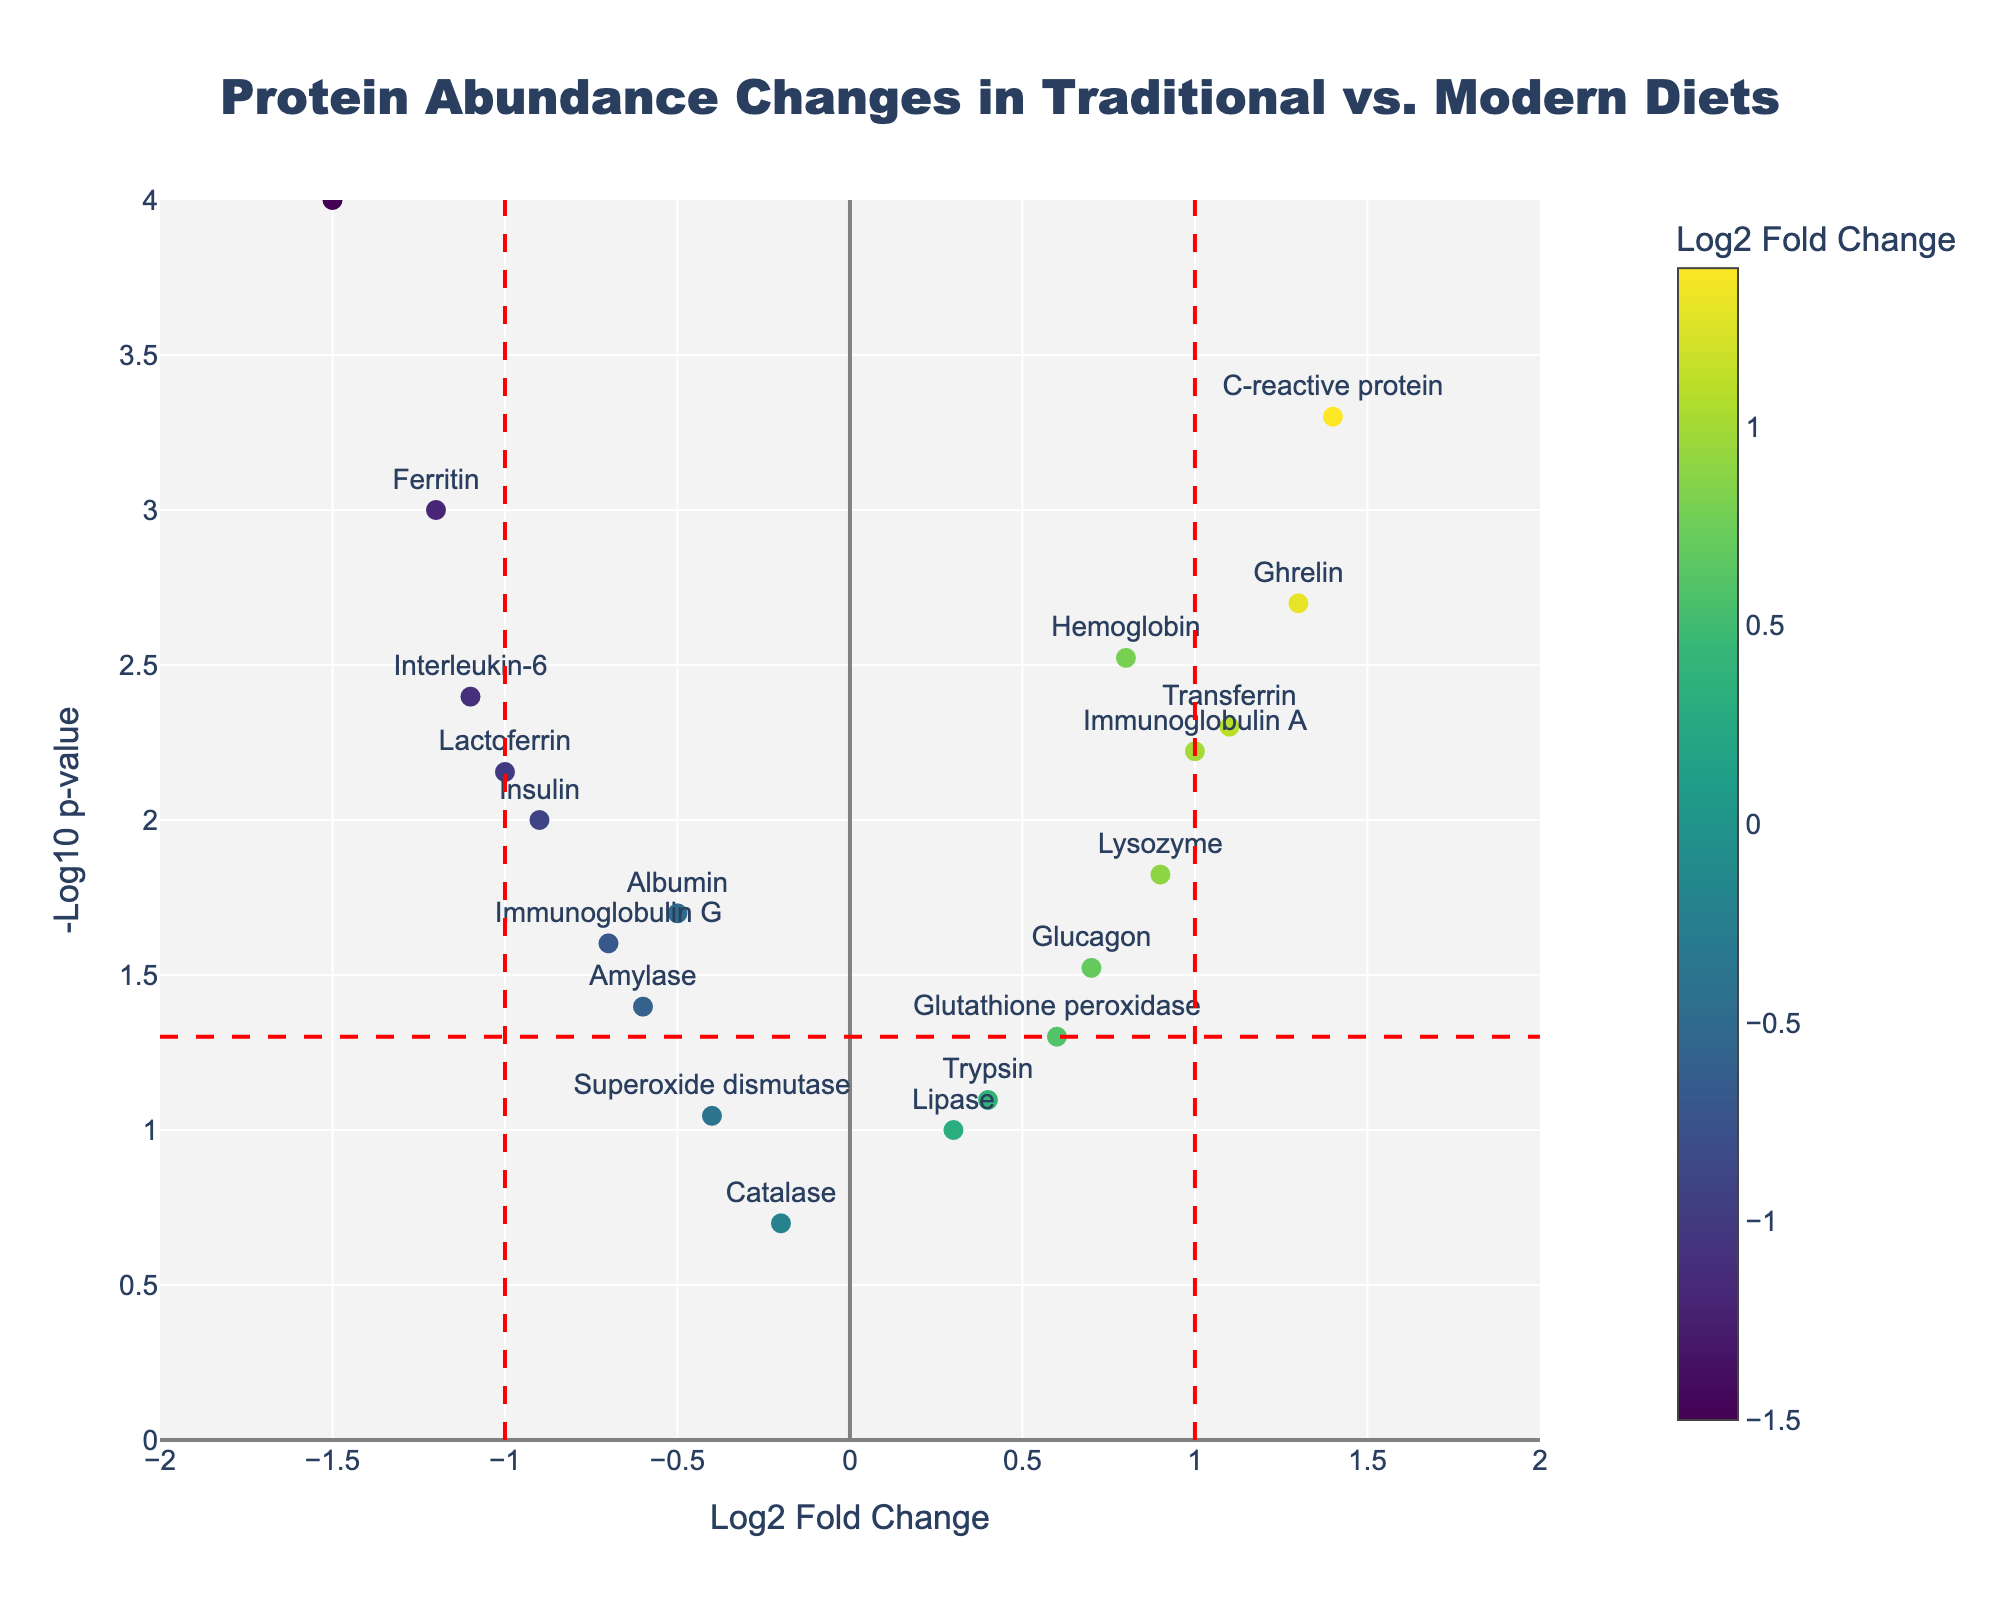What is the main title of the plot? The title is usually prominently displayed at the top of the plot and is meant to describe what the plot is about.
Answer: Protein Abundance Changes in Traditional vs. Modern Diets How many proteins have a log2 fold change greater than 1? To determine this, look at the x-axis (Log2 Fold Change) and count the number of data points (dots) to the right of the vertical line at 1.
Answer: 3 Which protein has the most significant p-value? The most significant p-value corresponds to the highest -log10(p-value). Look for the highest point on the y-axis.
Answer: Leptin What are the colors used to represent different levels of Log2 Fold Change? The colors on the plot show a gradient from one color to another, represented by the colorscale on the right side of the plot. Identify the range of colors on the colorscale.
Answer: Viridis (a gradient from purple to yellow-green) Which proteins are more abundant in traditional diets than modern diets? The proteins with negative log2 fold change values (left side of the x-axis) are more abundant in traditional diets. Look at the labels of the dots on the negative side.
Answer: Ferritin, Albumin, Leptin, Insulin, Amylase, Lactoferrin, Immunoglobulin G, Interleukin-6 How many proteins have a p-value less than 0.05? A p-value less than 0.05 corresponds to -log10(p-value) greater than -log10(0.05). Count the number of points above the horizontal line for -log10(0.05).
Answer: 14 Which protein shows a greater difference in abundance, C-reactive protein or Transferrin? Compare the log2 fold change values of C-reactive protein and Transferrin by reading their positions along the x-axis.
Answer: C-reactive protein What is the log2 fold change for Hemoglobin? Locate the Hemoglobin on the plot and read its position along the x-axis.
Answer: 0.8 Which protein has a higher p-value, Catalase or Lipase? Compare the position of Catalase and Lipase along the y-axis where p-values are represented as -log10(p-value). The closer to the bottom, the higher the p-value.
Answer: Catalase What is the -log10(p-value) for Immunoglobulin A? Find Immunoglobulin A on the plot, and its y-axis value represents -log10(p-value).
Answer: Approximately 2.22 